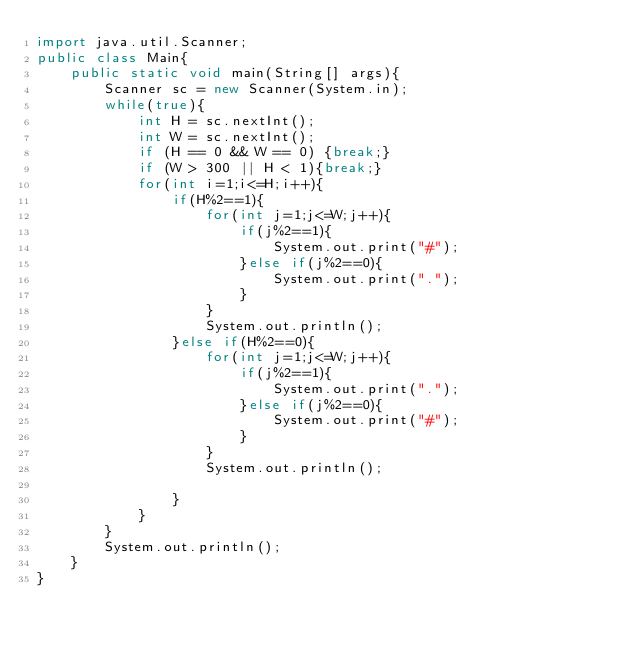Convert code to text. <code><loc_0><loc_0><loc_500><loc_500><_Java_>import java.util.Scanner;
public class Main{
    public static void main(String[] args){
        Scanner sc = new Scanner(System.in);
        while(true){
            int H = sc.nextInt();
            int W = sc.nextInt();
            if (H == 0 && W == 0) {break;}
            if (W > 300 || H < 1){break;}
            for(int i=1;i<=H;i++){
                if(H%2==1){
                    for(int j=1;j<=W;j++){
                        if(j%2==1){
                            System.out.print("#");
                        }else if(j%2==0){
                            System.out.print(".");
                        }
                    }
                    System.out.println();
                }else if(H%2==0){
                    for(int j=1;j<=W;j++){
                        if(j%2==1){
                            System.out.print(".");
                        }else if(j%2==0){
                            System.out.print("#");
                        }
                    }
                    System.out.println();

                }
            }
        }
        System.out.println();
    }
}
</code> 